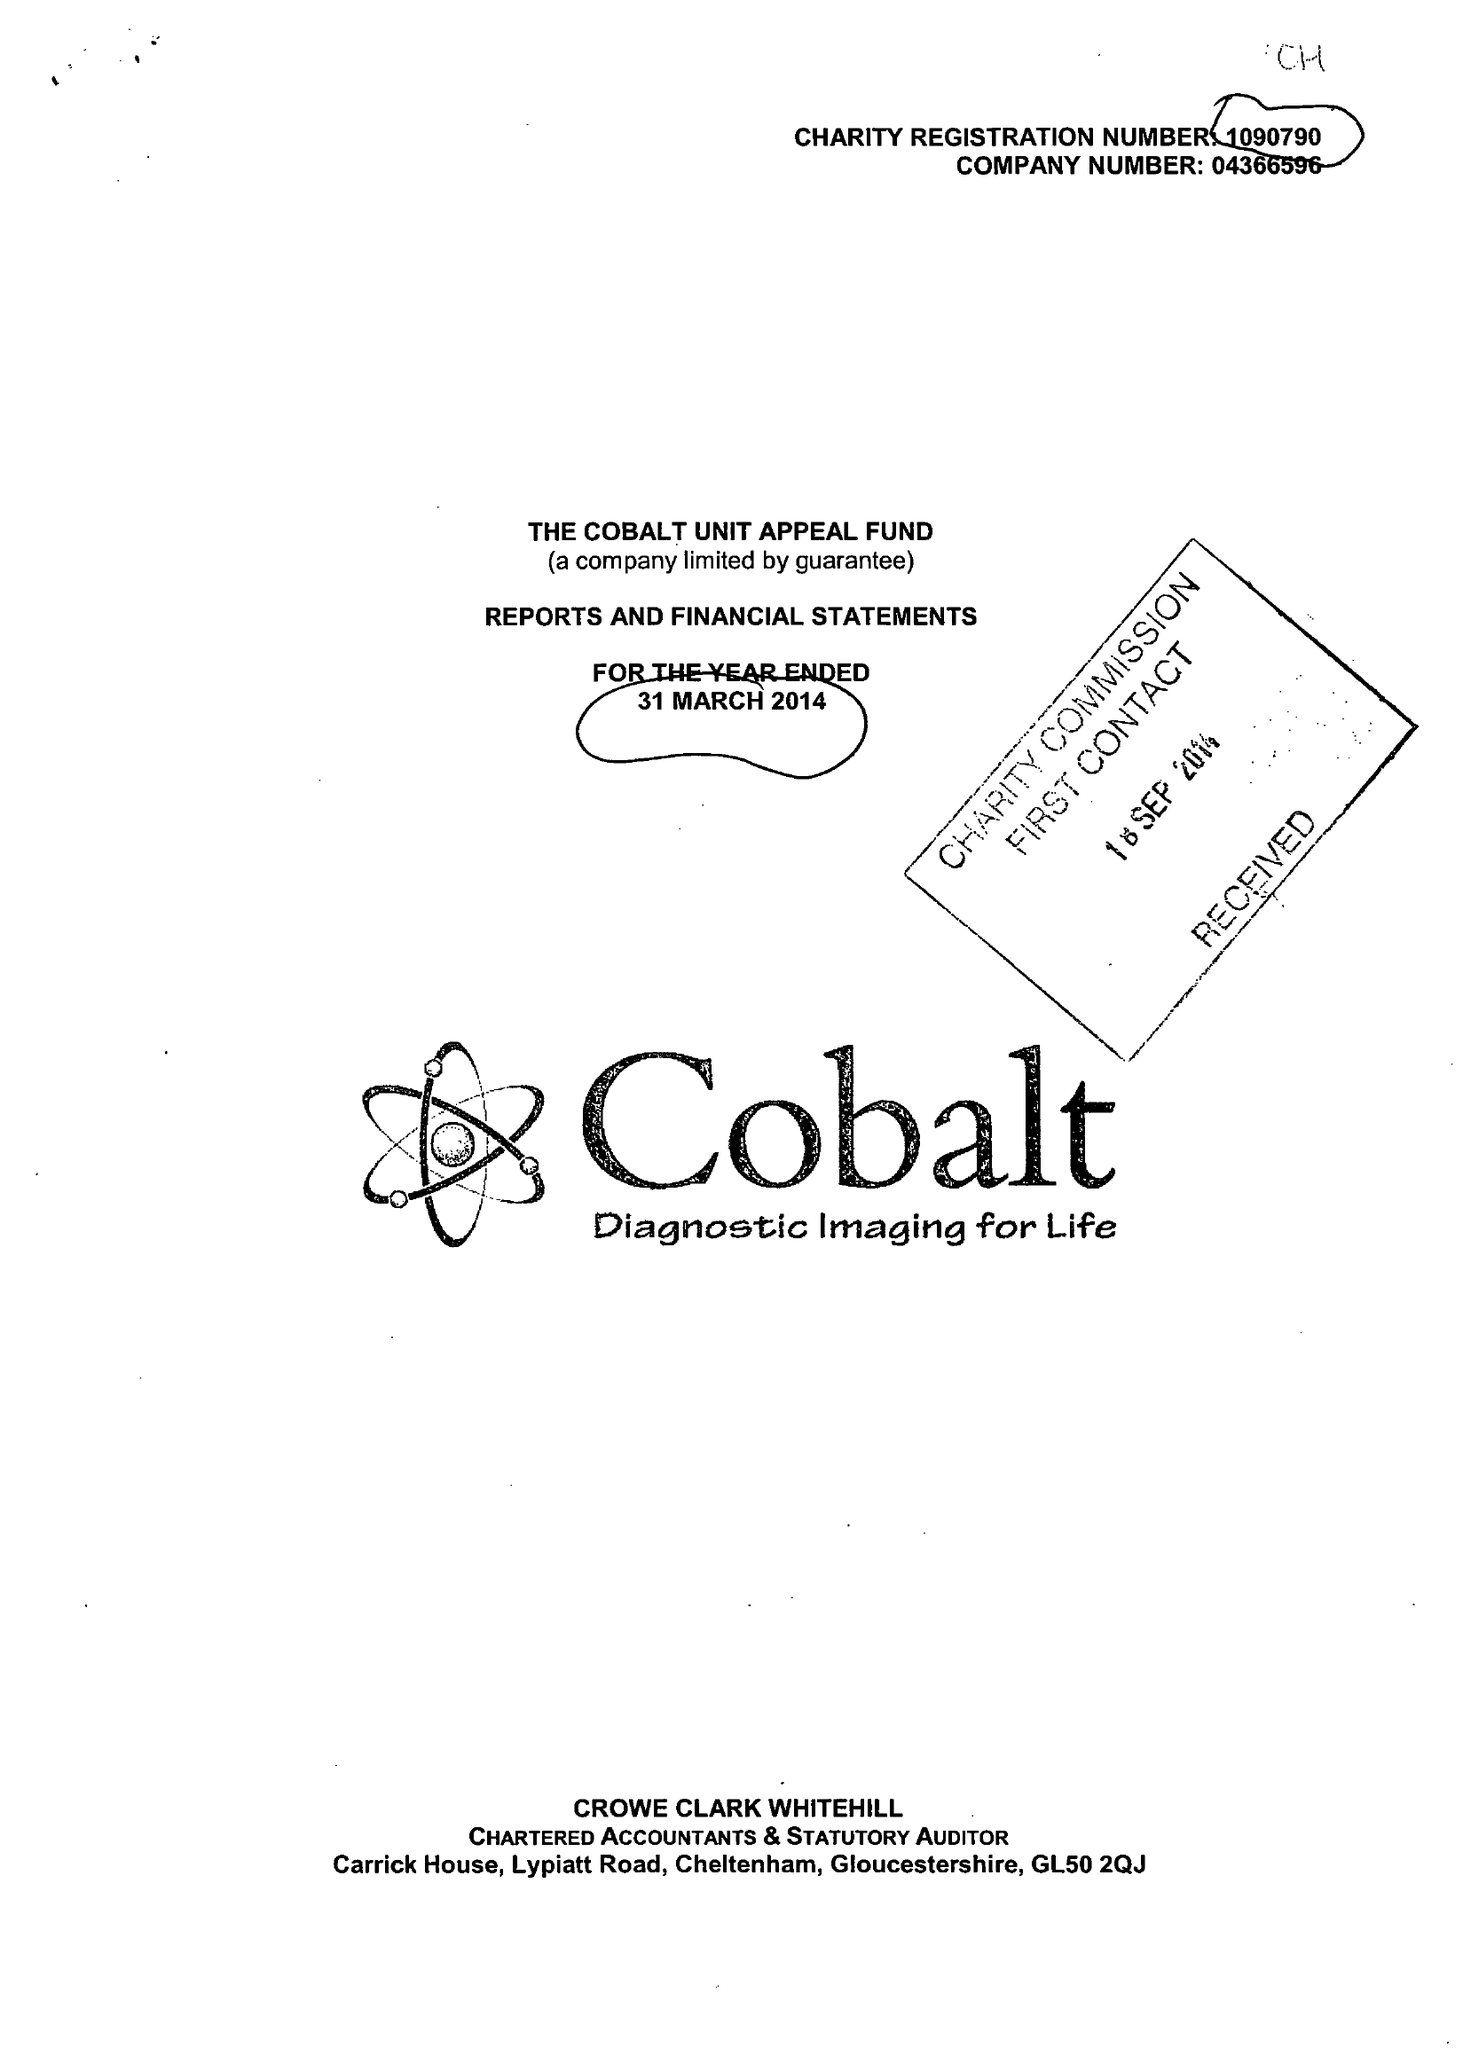What is the value for the report_date?
Answer the question using a single word or phrase. 2014-03-31 